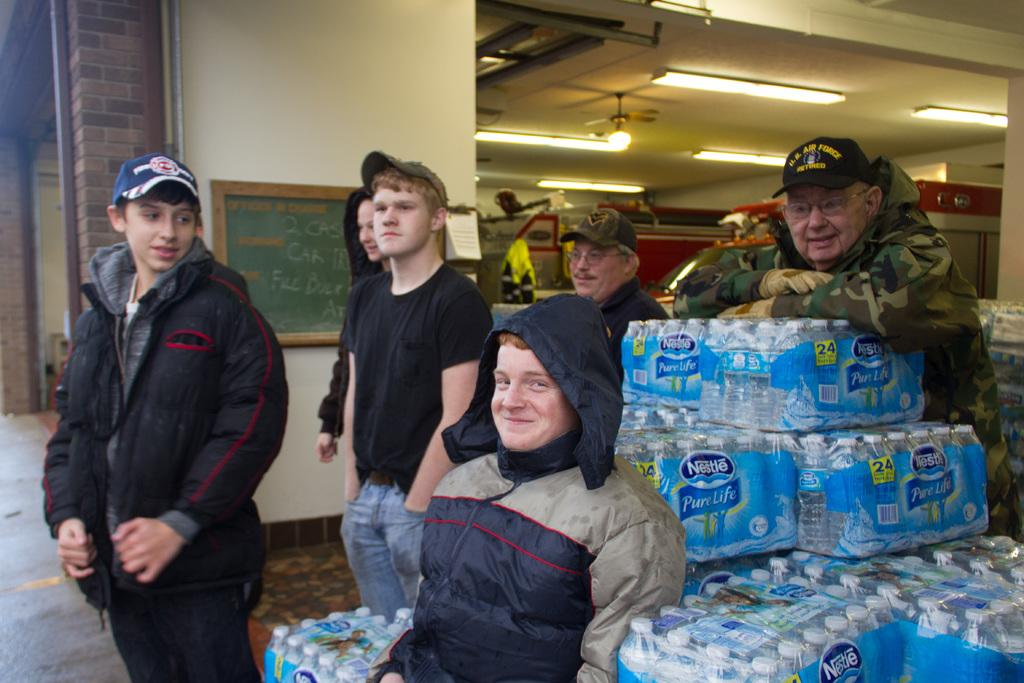What are the people in the image doing? The people in the image are standing. Can you describe the position of one of the people? One person is sitting on water bottles. What can be seen in the background of the image? There is a pillar in the background of the image. What is above the people in the image? There is a ceiling visible in the image. What is providing illumination in the image? Lights are present in the image. What type of hobbies do the people in the image enjoy? There is no information about the hobbies of the people in the image. Can you tell me how many beds are visible in the image? There are no beds present in the image. 